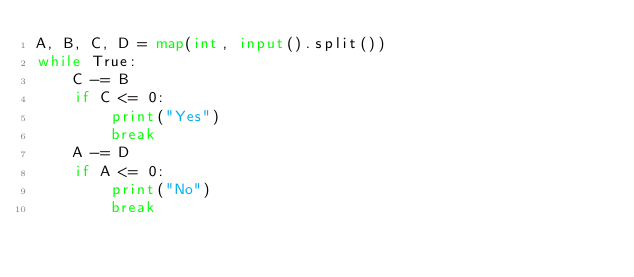<code> <loc_0><loc_0><loc_500><loc_500><_Python_>A, B, C, D = map(int, input().split())
while True:
    C -= B
    if C <= 0:
        print("Yes")
        break
    A -= D
    if A <= 0:
        print("No")
        break</code> 